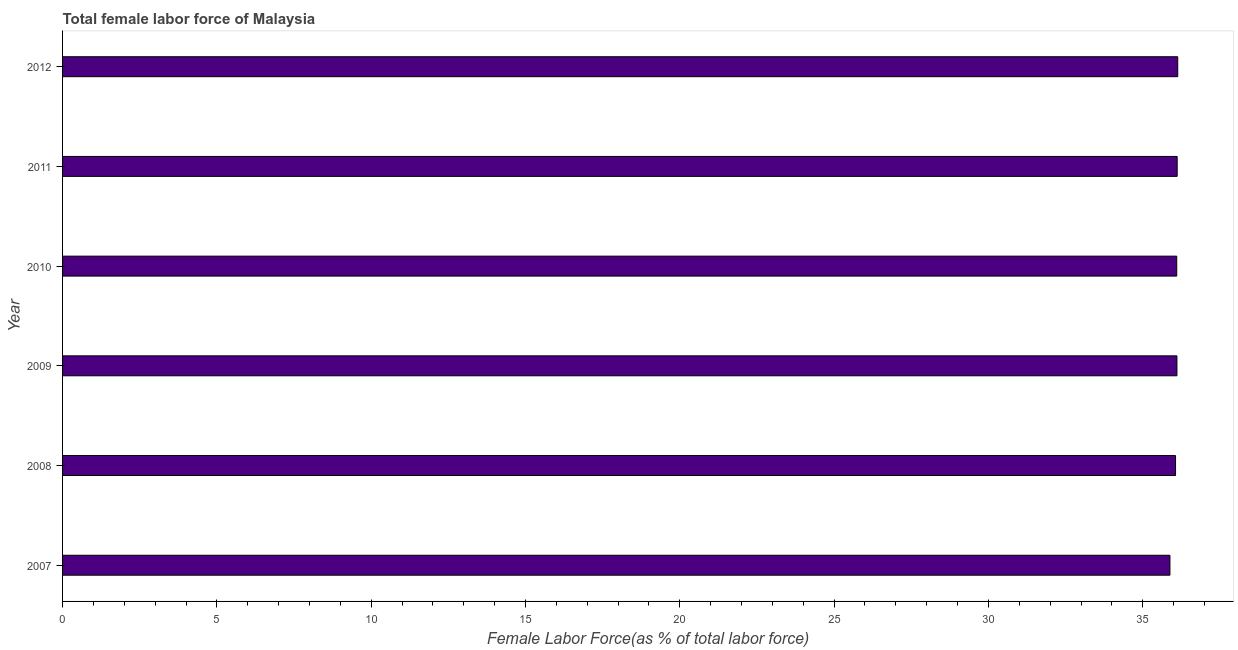Does the graph contain any zero values?
Ensure brevity in your answer.  No. Does the graph contain grids?
Offer a terse response. No. What is the title of the graph?
Give a very brief answer. Total female labor force of Malaysia. What is the label or title of the X-axis?
Give a very brief answer. Female Labor Force(as % of total labor force). What is the label or title of the Y-axis?
Make the answer very short. Year. What is the total female labor force in 2011?
Your answer should be compact. 36.12. Across all years, what is the maximum total female labor force?
Your answer should be very brief. 36.13. Across all years, what is the minimum total female labor force?
Make the answer very short. 35.88. In which year was the total female labor force minimum?
Make the answer very short. 2007. What is the sum of the total female labor force?
Provide a succinct answer. 216.4. What is the difference between the total female labor force in 2007 and 2012?
Provide a short and direct response. -0.25. What is the average total female labor force per year?
Provide a succinct answer. 36.07. What is the median total female labor force?
Your answer should be very brief. 36.1. In how many years, is the total female labor force greater than 15 %?
Ensure brevity in your answer.  6. Do a majority of the years between 2011 and 2010 (inclusive) have total female labor force greater than 23 %?
Ensure brevity in your answer.  No. What is the ratio of the total female labor force in 2008 to that in 2010?
Give a very brief answer. 1. What is the difference between the highest and the second highest total female labor force?
Your response must be concise. 0.02. Is the sum of the total female labor force in 2008 and 2009 greater than the maximum total female labor force across all years?
Offer a terse response. Yes. How many bars are there?
Keep it short and to the point. 6. What is the difference between two consecutive major ticks on the X-axis?
Make the answer very short. 5. What is the Female Labor Force(as % of total labor force) in 2007?
Make the answer very short. 35.88. What is the Female Labor Force(as % of total labor force) of 2008?
Offer a very short reply. 36.06. What is the Female Labor Force(as % of total labor force) in 2009?
Provide a succinct answer. 36.11. What is the Female Labor Force(as % of total labor force) in 2010?
Offer a very short reply. 36.1. What is the Female Labor Force(as % of total labor force) in 2011?
Give a very brief answer. 36.12. What is the Female Labor Force(as % of total labor force) in 2012?
Offer a terse response. 36.13. What is the difference between the Female Labor Force(as % of total labor force) in 2007 and 2008?
Provide a succinct answer. -0.18. What is the difference between the Female Labor Force(as % of total labor force) in 2007 and 2009?
Your answer should be very brief. -0.23. What is the difference between the Female Labor Force(as % of total labor force) in 2007 and 2010?
Provide a succinct answer. -0.22. What is the difference between the Female Labor Force(as % of total labor force) in 2007 and 2011?
Offer a very short reply. -0.23. What is the difference between the Female Labor Force(as % of total labor force) in 2007 and 2012?
Your answer should be very brief. -0.25. What is the difference between the Female Labor Force(as % of total labor force) in 2008 and 2009?
Ensure brevity in your answer.  -0.05. What is the difference between the Female Labor Force(as % of total labor force) in 2008 and 2010?
Offer a very short reply. -0.04. What is the difference between the Female Labor Force(as % of total labor force) in 2008 and 2011?
Provide a succinct answer. -0.05. What is the difference between the Female Labor Force(as % of total labor force) in 2008 and 2012?
Give a very brief answer. -0.07. What is the difference between the Female Labor Force(as % of total labor force) in 2009 and 2010?
Provide a short and direct response. 0.01. What is the difference between the Female Labor Force(as % of total labor force) in 2009 and 2011?
Offer a very short reply. -0.01. What is the difference between the Female Labor Force(as % of total labor force) in 2009 and 2012?
Offer a very short reply. -0.03. What is the difference between the Female Labor Force(as % of total labor force) in 2010 and 2011?
Your response must be concise. -0.01. What is the difference between the Female Labor Force(as % of total labor force) in 2010 and 2012?
Your answer should be compact. -0.03. What is the difference between the Female Labor Force(as % of total labor force) in 2011 and 2012?
Offer a very short reply. -0.02. What is the ratio of the Female Labor Force(as % of total labor force) in 2007 to that in 2009?
Offer a terse response. 0.99. What is the ratio of the Female Labor Force(as % of total labor force) in 2007 to that in 2010?
Make the answer very short. 0.99. What is the ratio of the Female Labor Force(as % of total labor force) in 2008 to that in 2009?
Offer a very short reply. 1. What is the ratio of the Female Labor Force(as % of total labor force) in 2008 to that in 2010?
Provide a short and direct response. 1. What is the ratio of the Female Labor Force(as % of total labor force) in 2008 to that in 2012?
Make the answer very short. 1. What is the ratio of the Female Labor Force(as % of total labor force) in 2010 to that in 2011?
Give a very brief answer. 1. 